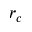Convert formula to latex. <formula><loc_0><loc_0><loc_500><loc_500>r _ { c }</formula> 